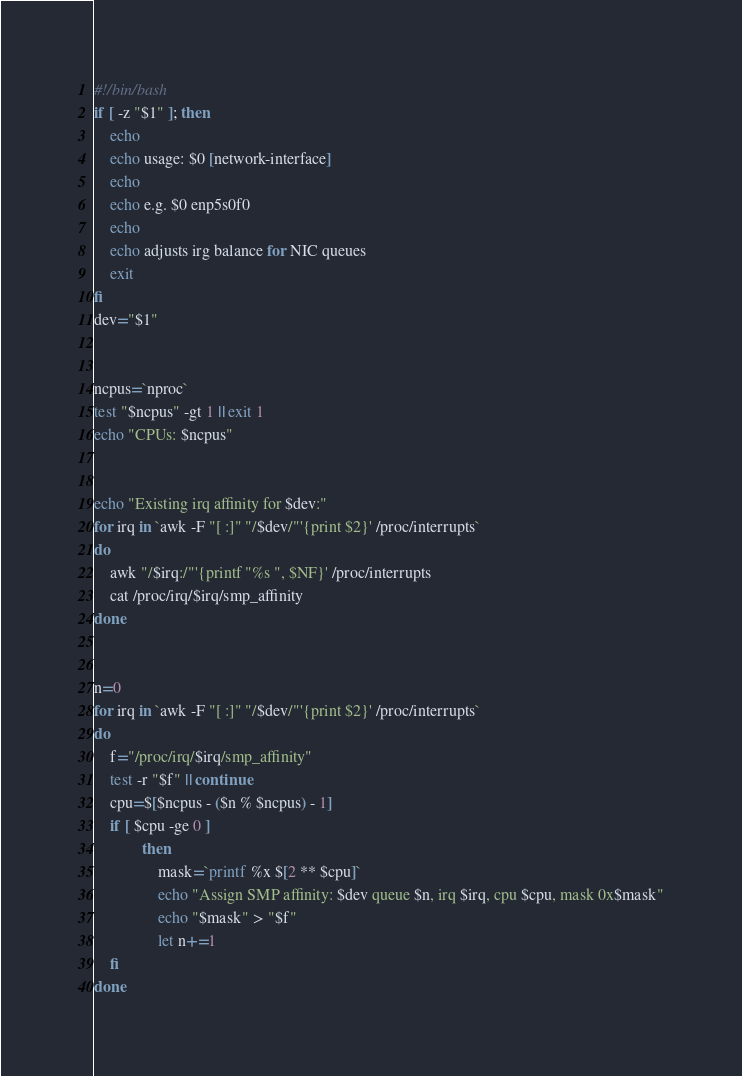Convert code to text. <code><loc_0><loc_0><loc_500><loc_500><_Bash_>#!/bin/bash
if [ -z "$1" ]; then
    echo
    echo usage: $0 [network-interface]
    echo
    echo e.g. $0 enp5s0f0
    echo
    echo adjusts irg balance for NIC queues
    exit
fi
dev="$1"


ncpus=`nproc`
test "$ncpus" -gt 1 || exit 1
echo "CPUs: $ncpus"


echo "Existing irq affinity for $dev:"
for irq in `awk -F "[ :]" "/$dev/"'{print $2}' /proc/interrupts`
do
    awk "/$irq:/"'{printf "%s ", $NF}' /proc/interrupts
    cat /proc/irq/$irq/smp_affinity
done


n=0
for irq in `awk -F "[ :]" "/$dev/"'{print $2}' /proc/interrupts`
do
    f="/proc/irq/$irq/smp_affinity"
    test -r "$f" || continue
    cpu=$[$ncpus - ($n % $ncpus) - 1]
    if [ $cpu -ge 0 ]
            then
                mask=`printf %x $[2 ** $cpu]`
                echo "Assign SMP affinity: $dev queue $n, irq $irq, cpu $cpu, mask 0x$mask"
                echo "$mask" > "$f"
                let n+=1
    fi
done</code> 